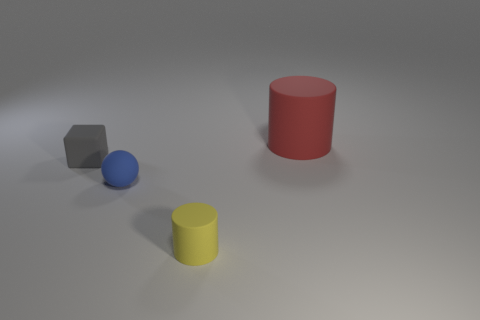Add 3 big red cylinders. How many objects exist? 7 Subtract all cubes. How many objects are left? 3 Add 1 tiny yellow rubber cylinders. How many tiny yellow rubber cylinders exist? 2 Subtract 0 gray balls. How many objects are left? 4 Subtract all tiny gray matte blocks. Subtract all tiny matte objects. How many objects are left? 0 Add 3 small cylinders. How many small cylinders are left? 4 